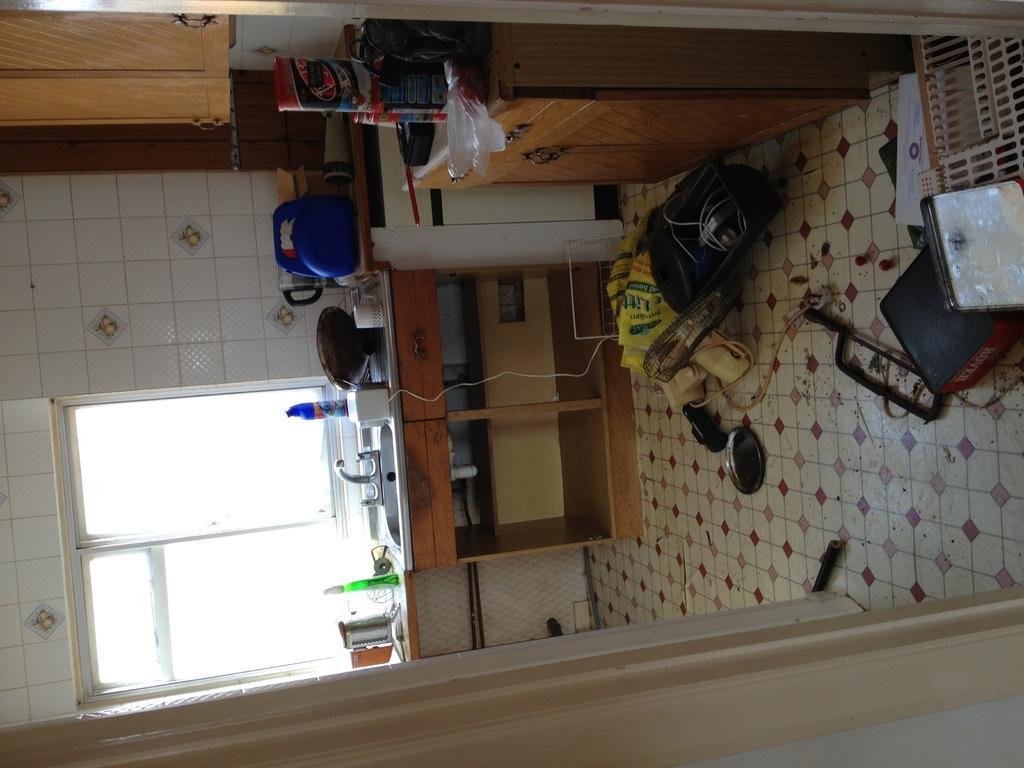Could you give a brief overview of what you see in this image? In this image I can see few drawers, cupboards, few bottles, a white colour mug, a sink, water tap and on floor I can see few boxes, a tool, a plate, a fan, a bag and a yellow colour thing. I can also see many more other stuffs over here. 